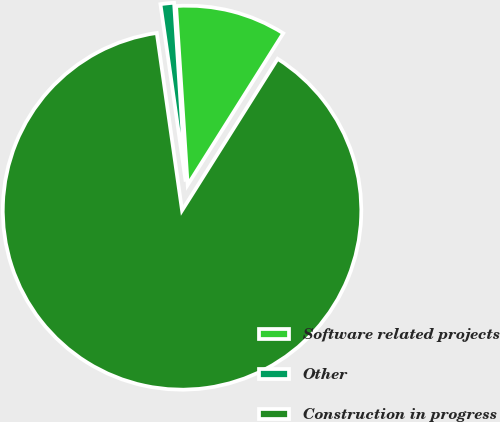Convert chart to OTSL. <chart><loc_0><loc_0><loc_500><loc_500><pie_chart><fcel>Software related projects<fcel>Other<fcel>Construction in progress<nl><fcel>9.98%<fcel>1.22%<fcel>88.8%<nl></chart> 